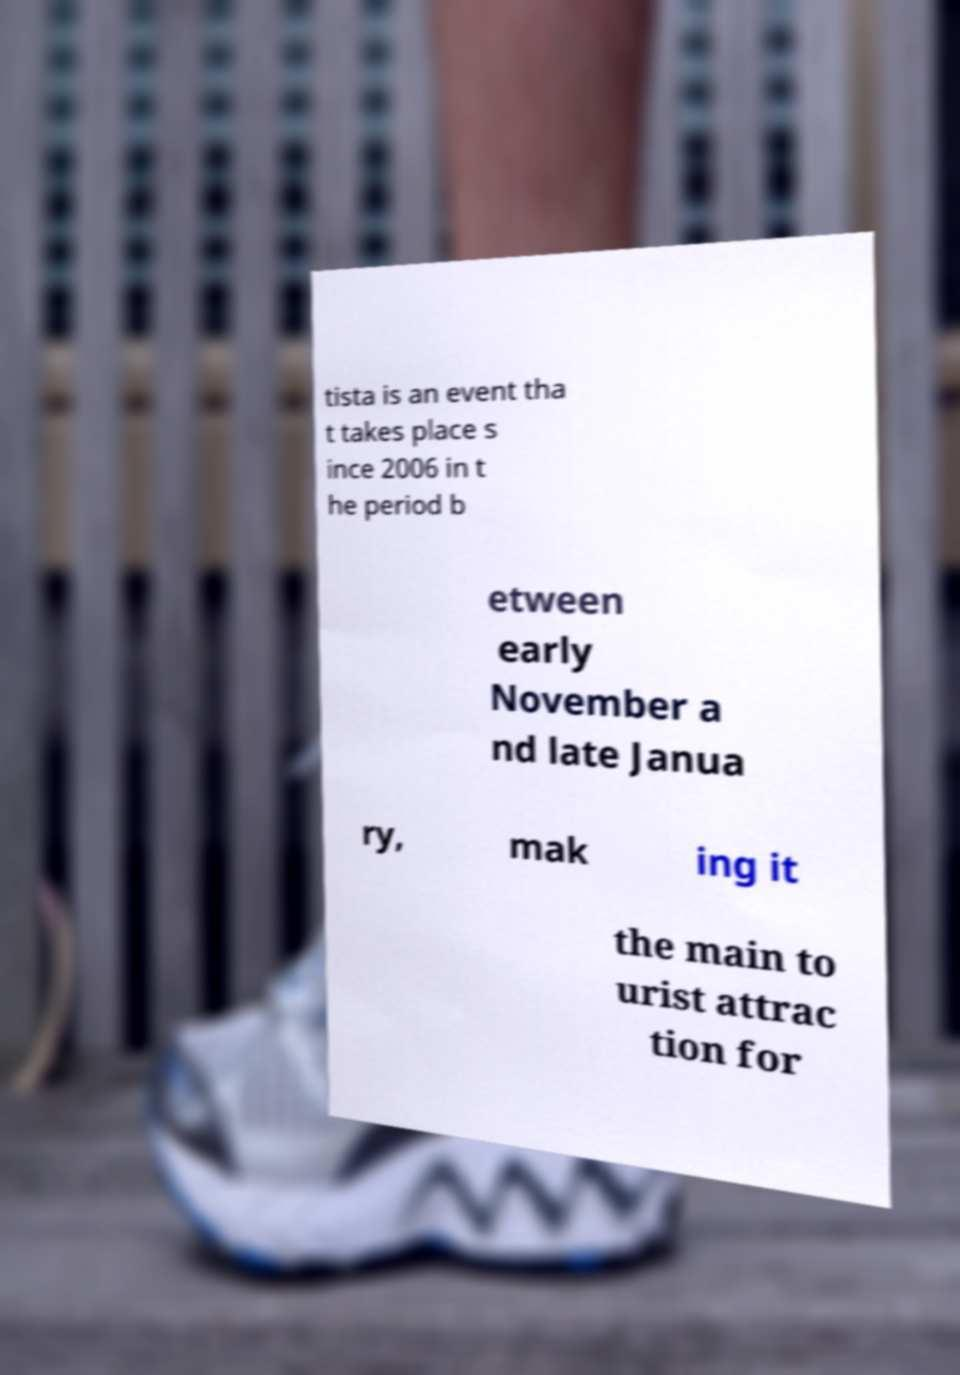There's text embedded in this image that I need extracted. Can you transcribe it verbatim? tista is an event tha t takes place s ince 2006 in t he period b etween early November a nd late Janua ry, mak ing it the main to urist attrac tion for 